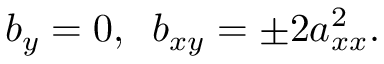<formula> <loc_0><loc_0><loc_500><loc_500>b _ { y } = 0 , \, b _ { x y } = \pm 2 a _ { x x } ^ { 2 } .</formula> 